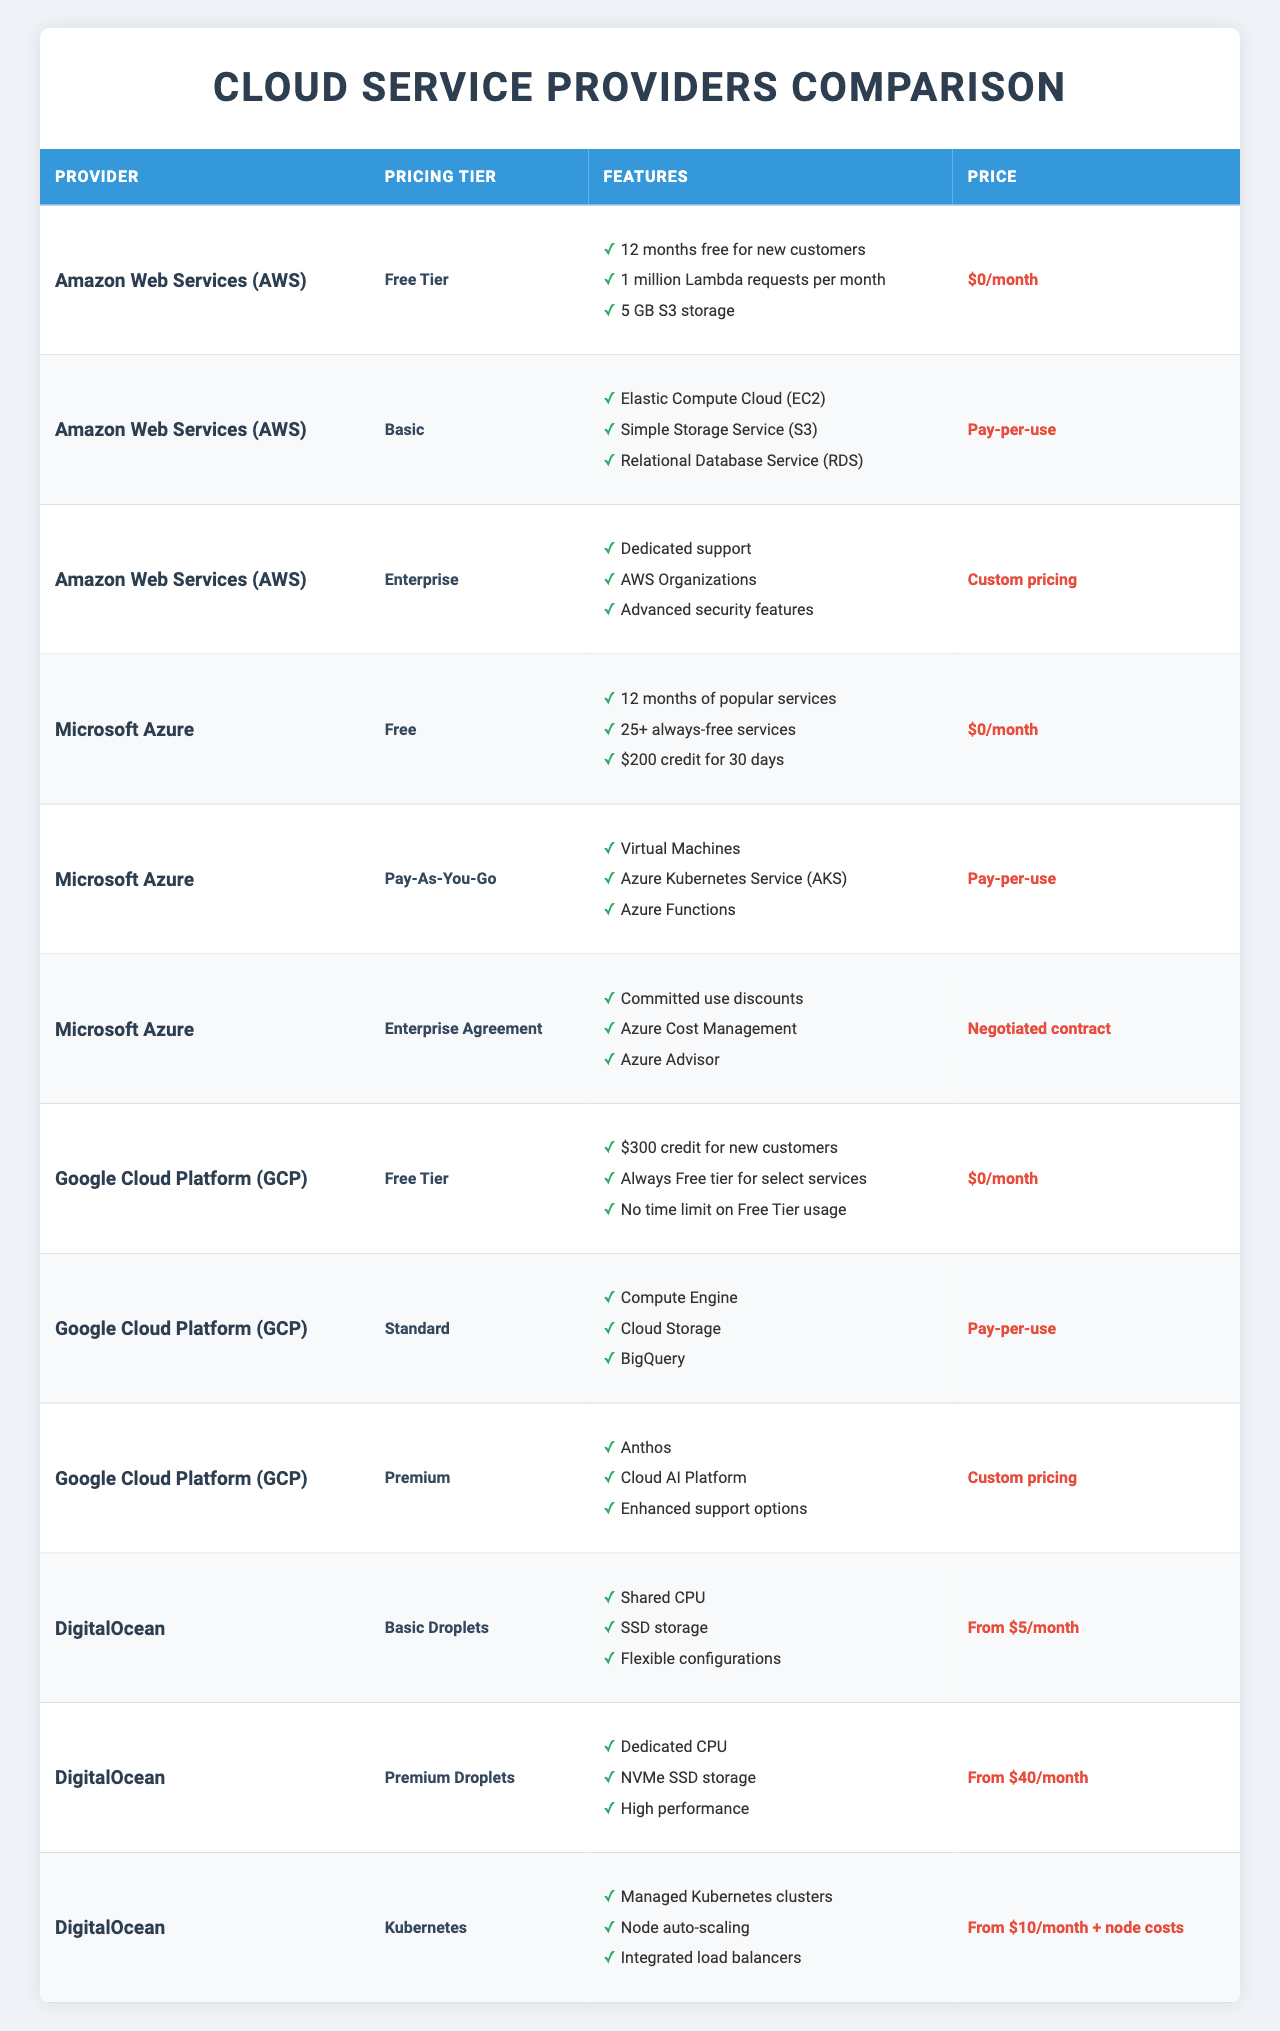What is the price of the Free Tier offered by AWS? The table lists the pricing tier for AWS's Free Tier, which shows the price is "$0/month".
Answer: $0/month What features are included in the Premium tier of Google Cloud Platform? The table details that the Premium tier includes "Anthos", "Cloud AI Platform", and "Enhanced support options".
Answer: Anthos, Cloud AI Platform, Enhanced support options Which provider offers dedicated CPU in their Premium Droplets tier? By examining the table, it can be seen that DigitalOcean offers a Premium Droplets tier which features "Dedicated CPU".
Answer: DigitalOcean Is there a custom pricing option available for any of the providers? Yes, the table indicates that both AWS (Enterprise tier) and Google Cloud Platform (Premium tier) have "Custom pricing" listed.
Answer: Yes What is the total number of distinct pricing tiers listed for Microsoft Azure? The table shows three pricing tiers for Microsoft Azure: Free, Pay-As-You-Go, and Enterprise Agreement, totaling three distinct tiers.
Answer: 3 Which pricing tier from Amazon Web Services provides dedicated support? The table reveals that the Enterprise tier from AWS offers "Dedicated support".
Answer: Enterprise Compare the starting prices of basic and premium offerings of DigitalOcean. DigitalOcean has a starting price of "From $5/month" for Basic Droplets and "From $40/month" for Premium Droplets. The difference is $40 - $5 = $35, so Premium is significantly higher.
Answer: $35 What percentage of the total pricing tiers from all providers include free options? There are a total of 12 pricing tiers (3 from each of 4 providers). The free options are AWS Free Tier, Microsoft Azure Free, and Google Cloud Platform Free Tier, totaling 3 free tiers. Thus, the percentage is (3/12) * 100 = 25%.
Answer: 25% Does any provider offer a tier that includes compute services? Yes, all providers list tiers that include compute services: AWS (Elastic Compute Cloud), Microsoft Azure (Virtual Machines), GCP (Compute Engine), and DigitalOcean's Droplets.
Answer: Yes Which provider offers the lowest starting price for their basic tier? The table shows DigitalOcean's Basic Droplets starting at "$5/month", which is lower than AWS's and Azure's basic offerings, indicating DigitalOcean has the lowest starting price in this comparison.
Answer: DigitalOcean How many total features are listed under the Standard tier of Google Cloud Platform? The Standard tier of GCP lists three features: "Compute Engine", "Cloud Storage", and "BigQuery". Therefore, the total number of features is 3.
Answer: 3 